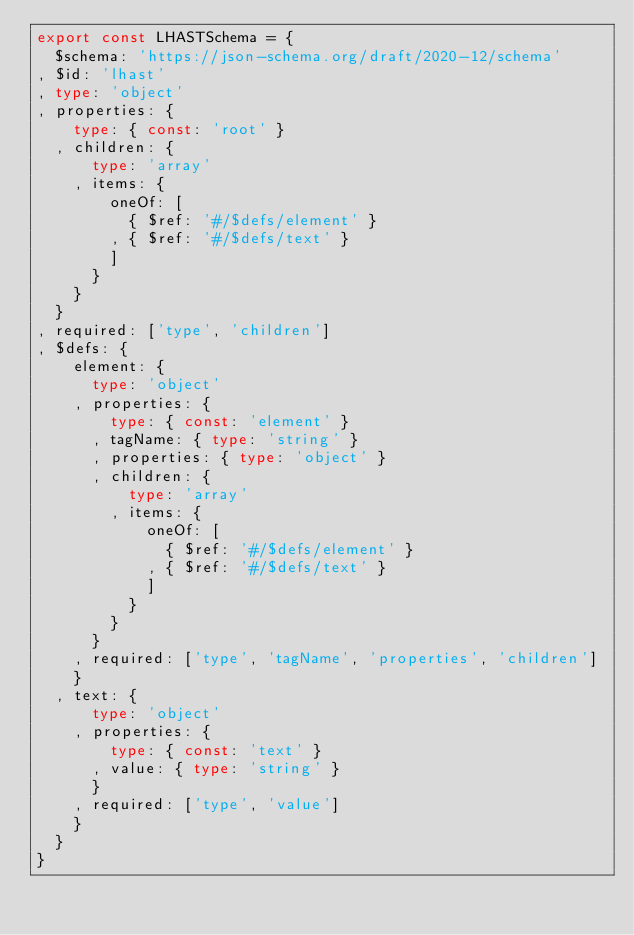Convert code to text. <code><loc_0><loc_0><loc_500><loc_500><_TypeScript_>export const LHASTSchema = {
  $schema: 'https://json-schema.org/draft/2020-12/schema'
, $id: 'lhast'
, type: 'object'
, properties: {
    type: { const: 'root' }
  , children: {
      type: 'array'
    , items: {
        oneOf: [
          { $ref: '#/$defs/element' }
        , { $ref: '#/$defs/text' }
        ]
      }
    }
  }
, required: ['type', 'children']
, $defs: {
    element: {
      type: 'object'
    , properties: {
        type: { const: 'element' }
      , tagName: { type: 'string' }
      , properties: { type: 'object' }
      , children: {
          type: 'array'
        , items: {
            oneOf: [
              { $ref: '#/$defs/element' }
            , { $ref: '#/$defs/text' }
            ]
          }
        }
      }
    , required: ['type', 'tagName', 'properties', 'children']
    }
  , text: {
      type: 'object'
    , properties: {
        type: { const: 'text' }
      , value: { type: 'string' }
      }
    , required: ['type', 'value']
    }
  }
}
</code> 